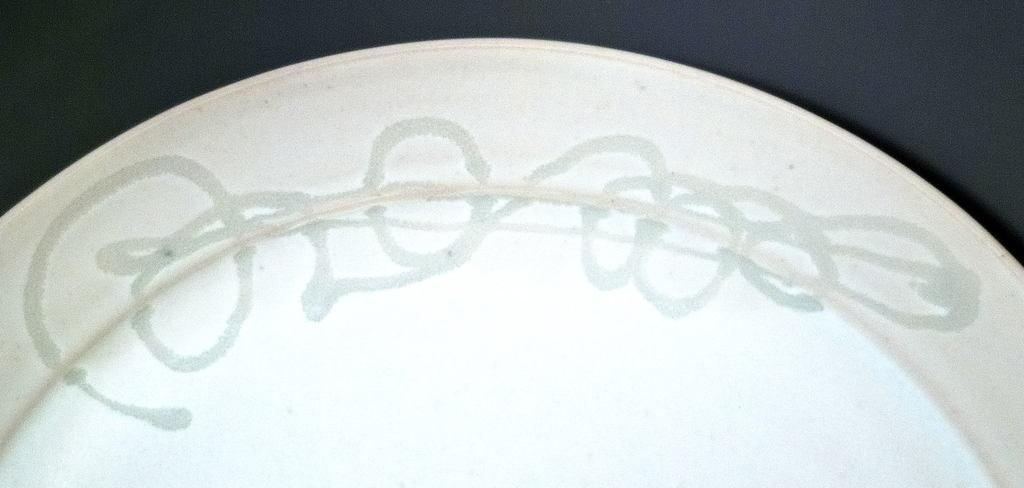What is present on the plate in the image? The facts provided do not specify what is on the plate. What is the color of the plate in the image? The plate is white in color. Does the plate have any unique features? Yes, the plate has a design. What is the color of the background in the image? The background of the image is black in color. How many dolls are sitting on the plate in the image? There are no dolls present in the image. What type of power source is used to light up the plate in the image? The plate does not have any lighting features, so there is no power source involved. 